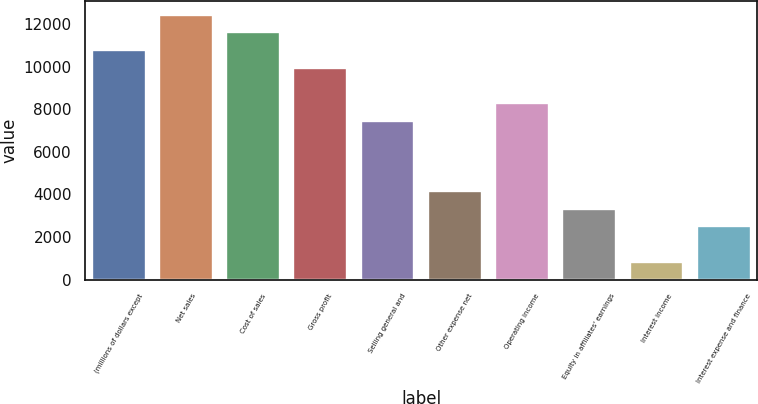<chart> <loc_0><loc_0><loc_500><loc_500><bar_chart><fcel>(millions of dollars except<fcel>Net sales<fcel>Cost of sales<fcel>Gross profit<fcel>Selling general and<fcel>Other expense net<fcel>Operating income<fcel>Equity in affiliates' earnings<fcel>Interest income<fcel>Interest expense and finance<nl><fcel>10795.7<fcel>12456.2<fcel>11625.9<fcel>9965.5<fcel>7474.84<fcel>4153.96<fcel>8305.06<fcel>3323.74<fcel>833.08<fcel>2493.52<nl></chart> 